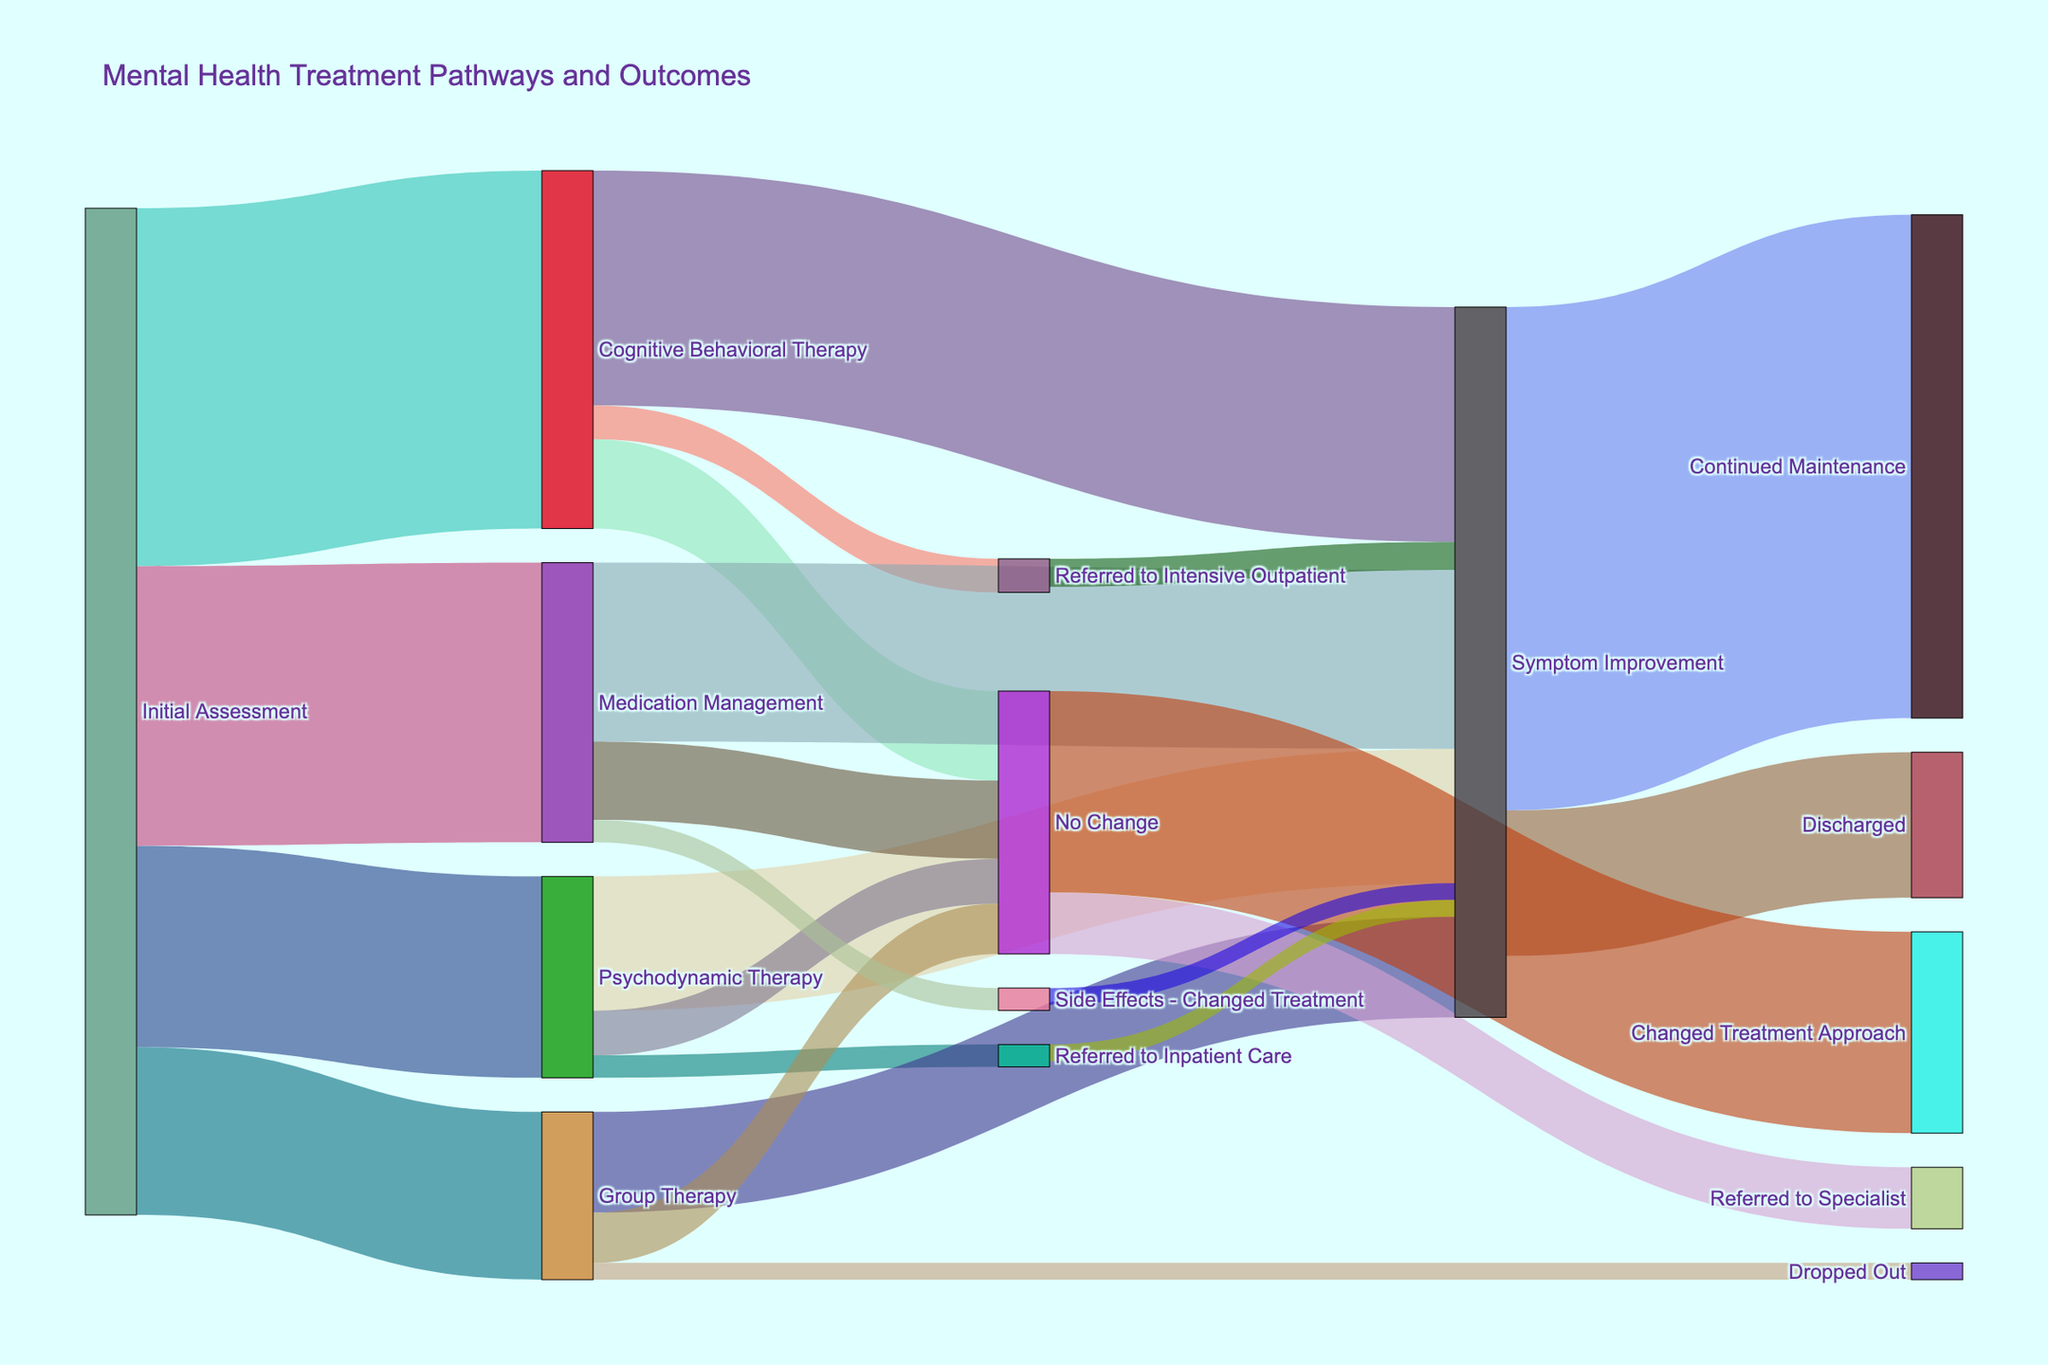What is the title of the Sankey Diagram? The title is usually at the top of the figure. In this Sankey Diagram, the title is "Mental Health Treatment Pathways and Outcomes".
Answer: Mental Health Treatment Pathways and Outcomes How many patients were initially assessed for treatment? By looking at the figure, we can see the total number of patients flowing into different treatment pathways from the 'Initial Assessment'. Summing the values for all the pathways: 320 (Cognitive Behavioral Therapy) + 180 (Psychodynamic Therapy) + 150 (Group Therapy) + 250 (Medication Management) = 900 patients.
Answer: 900 What are the possible outcomes after experiencing 'Symptom Improvement'? The figure shows that 'Symptom Improvement' can lead to either 'Continued Maintenance' or 'Discharged'. Follow the arrows from 'Symptom Improvement' to find this information.
Answer: Continued Maintenance, Discharged Which treatment pathway leads to the highest number of patients undergoing further treatment or referral? Compare the values of outgoing flows from different treatments to further steps like 'Referred to Intensive Outpatient', 'Referred to Inpatient Care', and 'Side Effects - Changed Treatment'. CBT has 30 patients (Referred to Intensive Outpatient), Psychodynamic Therapy has 20 (Referred to Inpatient Care), so CBT has the highest [30].
Answer: Cognitive Behavioral Therapy How many patients showed 'No Change' in their condition across all treatments? Add up the number of patients showing 'No Change' from each treatment pathway: 80 (Cognitive Behavioral Therapy) + 40 (Psychodynamic Therapy) + 45 (Group Therapy) + 70 (Medication Management) = 235.
Answer: 235 Between 'Cognitive Behavioral Therapy' and 'Medication Management', which one has a higher number of patients experiencing 'Symptom Improvement'? Look at the value of the flow from each treatment to 'Symptom Improvement': CBT has 210 and Medication Management has 160.
Answer: Cognitive Behavioral Therapy (210) What is the total number of patients who continued maintenance after treatment? The figure shows 'Continued Maintenance' with flows from 'Symptom Improvement'. Total value is given as 450 patients.
Answer: 450 How many patients switched their treatment approach after experiencing 'No Change'? Following from 'No Change', we see it has a branch leading to 'Changed Treatment Approach' with a value of 180.
Answer: 180 Which treatment pathway has the highest dropout rate? Look for 'Dropped Out' in the targets and trace back to the source. 'Group Therapy' is the only pathway with a dropout value of 15.
Answer: Group Therapy 